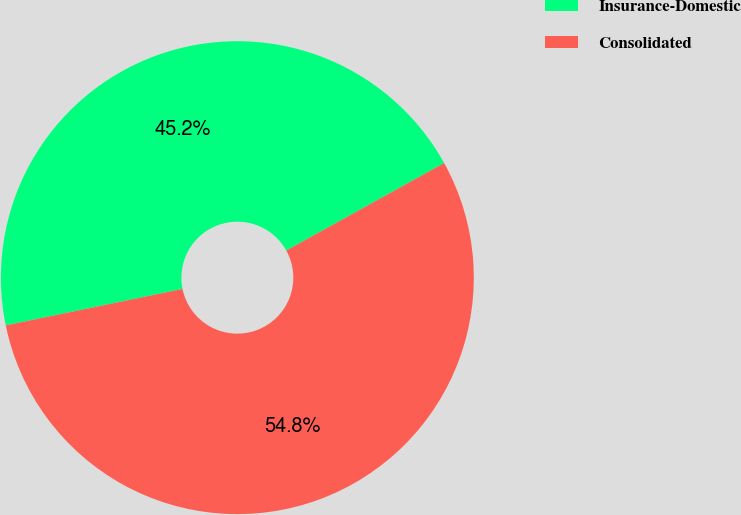Convert chart to OTSL. <chart><loc_0><loc_0><loc_500><loc_500><pie_chart><fcel>Insurance-Domestic<fcel>Consolidated<nl><fcel>45.18%<fcel>54.82%<nl></chart> 